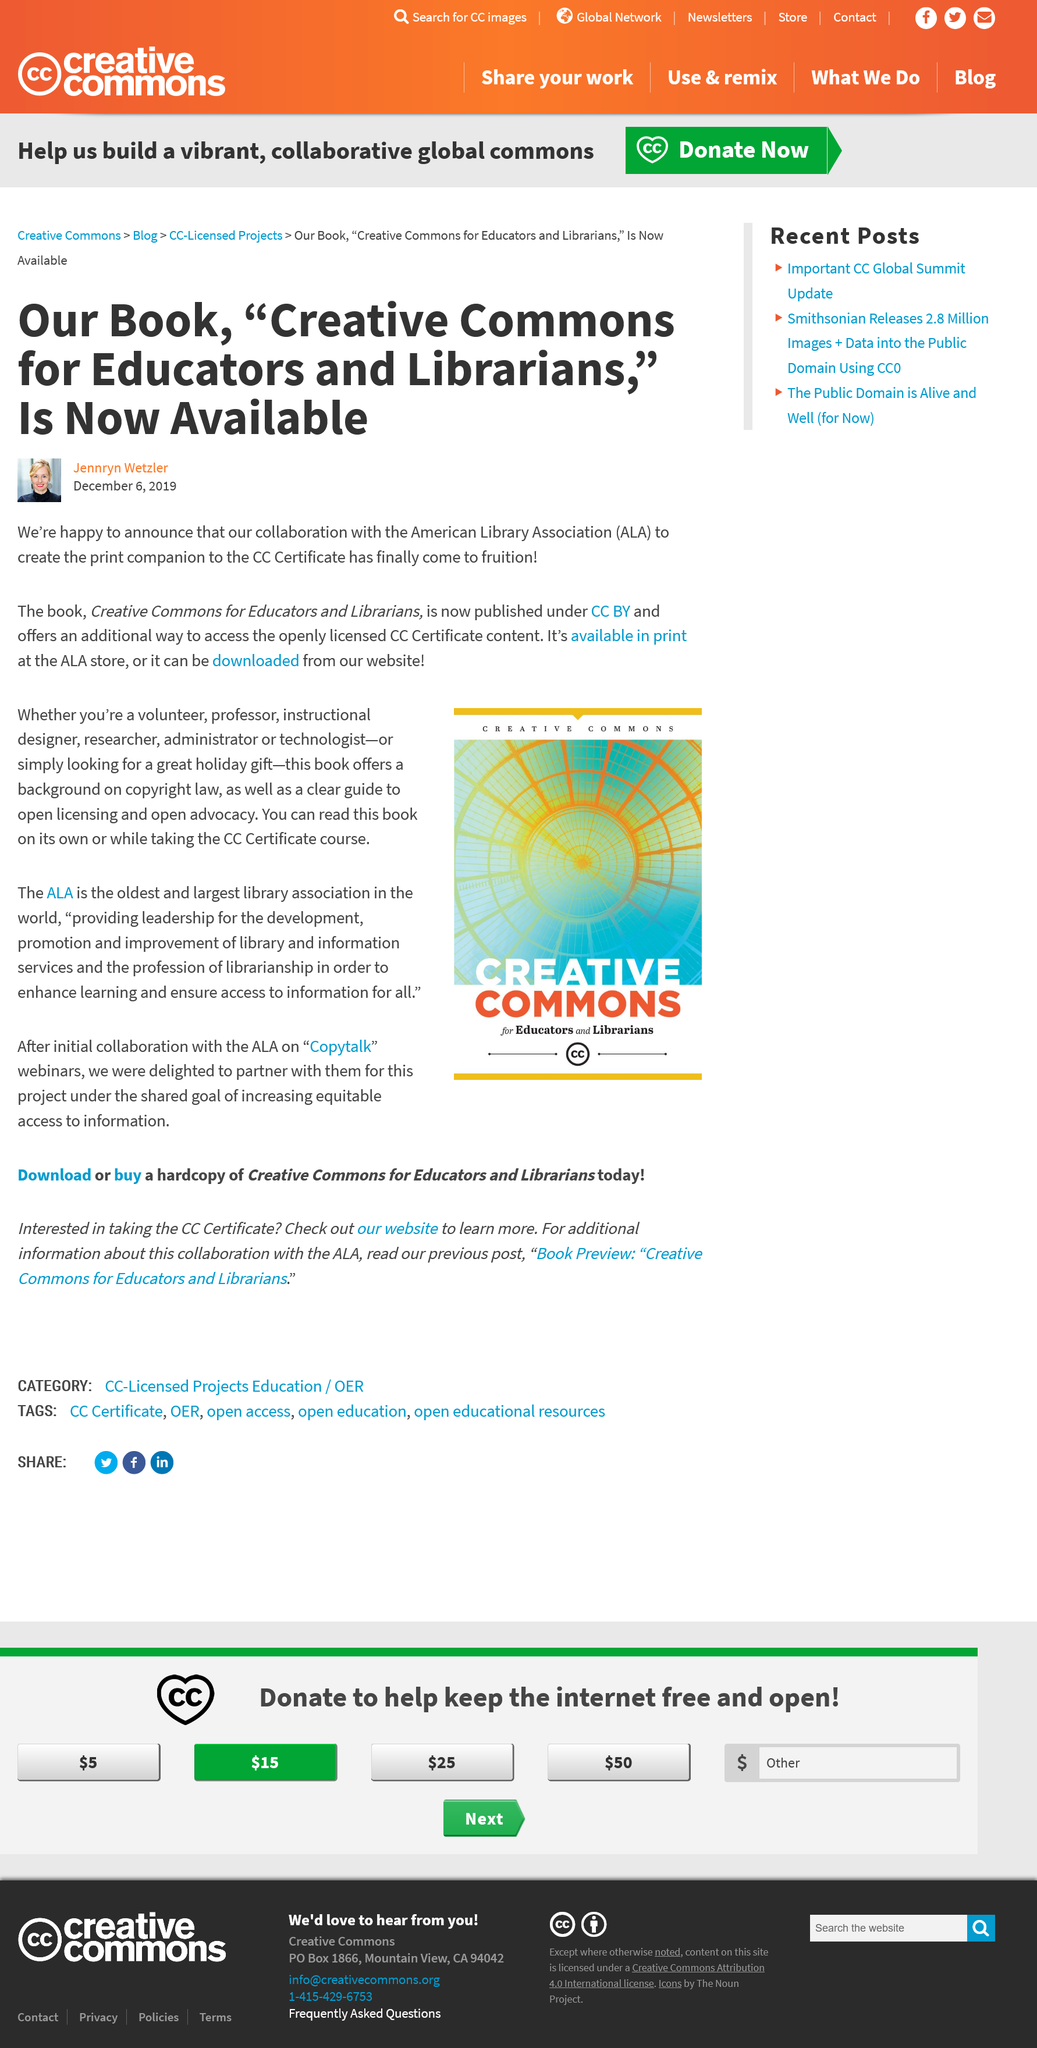Draw attention to some important aspects in this diagram. The collaboration between the American Library Association and our organization to create the print companion to the CC Certificate has resulted in the publication of the book Creative Commons for Educators and Librarians, which is now available. The book "Creative Commons for Educators and Librarians" can be obtained through the ALA store or downloaded from the organization's website. The book Creative Commons for Educators and Librarians is available in print or can be downloaded from the website. 